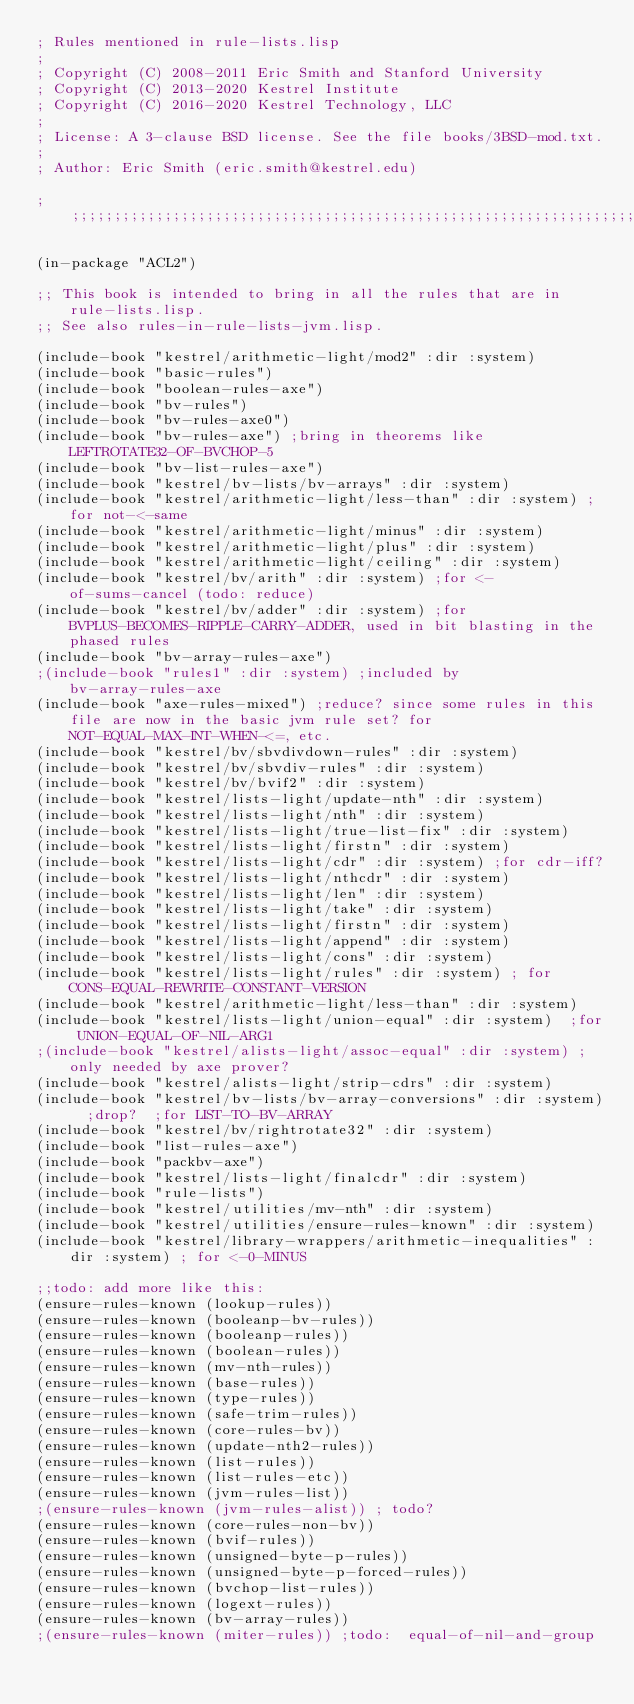Convert code to text. <code><loc_0><loc_0><loc_500><loc_500><_Lisp_>; Rules mentioned in rule-lists.lisp
;
; Copyright (C) 2008-2011 Eric Smith and Stanford University
; Copyright (C) 2013-2020 Kestrel Institute
; Copyright (C) 2016-2020 Kestrel Technology, LLC
;
; License: A 3-clause BSD license. See the file books/3BSD-mod.txt.
;
; Author: Eric Smith (eric.smith@kestrel.edu)

;;;;;;;;;;;;;;;;;;;;;;;;;;;;;;;;;;;;;;;;;;;;;;;;;;;;;;;;;;;;;;;;;;;;;;;;;;;;;;;;

(in-package "ACL2")

;; This book is intended to bring in all the rules that are in rule-lists.lisp.
;; See also rules-in-rule-lists-jvm.lisp.

(include-book "kestrel/arithmetic-light/mod2" :dir :system)
(include-book "basic-rules")
(include-book "boolean-rules-axe")
(include-book "bv-rules")
(include-book "bv-rules-axe0")
(include-book "bv-rules-axe") ;bring in theorems like LEFTROTATE32-OF-BVCHOP-5
(include-book "bv-list-rules-axe")
(include-book "kestrel/bv-lists/bv-arrays" :dir :system)
(include-book "kestrel/arithmetic-light/less-than" :dir :system) ;for not-<-same
(include-book "kestrel/arithmetic-light/minus" :dir :system)
(include-book "kestrel/arithmetic-light/plus" :dir :system)
(include-book "kestrel/arithmetic-light/ceiling" :dir :system)
(include-book "kestrel/bv/arith" :dir :system) ;for <-of-sums-cancel (todo: reduce)
(include-book "kestrel/bv/adder" :dir :system) ;for BVPLUS-BECOMES-RIPPLE-CARRY-ADDER, used in bit blasting in the phased rules
(include-book "bv-array-rules-axe")
;(include-book "rules1" :dir :system) ;included by bv-array-rules-axe
(include-book "axe-rules-mixed") ;reduce? since some rules in this file are now in the basic jvm rule set? for NOT-EQUAL-MAX-INT-WHEN-<=, etc.
(include-book "kestrel/bv/sbvdivdown-rules" :dir :system)
(include-book "kestrel/bv/sbvdiv-rules" :dir :system)
(include-book "kestrel/bv/bvif2" :dir :system)
(include-book "kestrel/lists-light/update-nth" :dir :system)
(include-book "kestrel/lists-light/nth" :dir :system)
(include-book "kestrel/lists-light/true-list-fix" :dir :system)
(include-book "kestrel/lists-light/firstn" :dir :system)
(include-book "kestrel/lists-light/cdr" :dir :system) ;for cdr-iff?
(include-book "kestrel/lists-light/nthcdr" :dir :system)
(include-book "kestrel/lists-light/len" :dir :system)
(include-book "kestrel/lists-light/take" :dir :system)
(include-book "kestrel/lists-light/firstn" :dir :system)
(include-book "kestrel/lists-light/append" :dir :system)
(include-book "kestrel/lists-light/cons" :dir :system)
(include-book "kestrel/lists-light/rules" :dir :system) ; for CONS-EQUAL-REWRITE-CONSTANT-VERSION
(include-book "kestrel/arithmetic-light/less-than" :dir :system)
(include-book "kestrel/lists-light/union-equal" :dir :system)  ;for UNION-EQUAL-OF-NIL-ARG1
;(include-book "kestrel/alists-light/assoc-equal" :dir :system) ;only needed by axe prover?
(include-book "kestrel/alists-light/strip-cdrs" :dir :system)
(include-book "kestrel/bv-lists/bv-array-conversions" :dir :system)  ;drop?  ;for LIST-TO-BV-ARRAY
(include-book "kestrel/bv/rightrotate32" :dir :system)
(include-book "list-rules-axe")
(include-book "packbv-axe")
(include-book "kestrel/lists-light/finalcdr" :dir :system)
(include-book "rule-lists")
(include-book "kestrel/utilities/mv-nth" :dir :system)
(include-book "kestrel/utilities/ensure-rules-known" :dir :system)
(include-book "kestrel/library-wrappers/arithmetic-inequalities" :dir :system) ; for <-0-MINUS

;;todo: add more like this:
(ensure-rules-known (lookup-rules))
(ensure-rules-known (booleanp-bv-rules))
(ensure-rules-known (booleanp-rules))
(ensure-rules-known (boolean-rules))
(ensure-rules-known (mv-nth-rules))
(ensure-rules-known (base-rules))
(ensure-rules-known (type-rules))
(ensure-rules-known (safe-trim-rules))
(ensure-rules-known (core-rules-bv))
(ensure-rules-known (update-nth2-rules))
(ensure-rules-known (list-rules))
(ensure-rules-known (list-rules-etc))
(ensure-rules-known (jvm-rules-list))
;(ensure-rules-known (jvm-rules-alist)) ; todo?
(ensure-rules-known (core-rules-non-bv))
(ensure-rules-known (bvif-rules))
(ensure-rules-known (unsigned-byte-p-rules))
(ensure-rules-known (unsigned-byte-p-forced-rules))
(ensure-rules-known (bvchop-list-rules))
(ensure-rules-known (logext-rules))
(ensure-rules-known (bv-array-rules))
;(ensure-rules-known (miter-rules)) ;todo:  equal-of-nil-and-group
</code> 